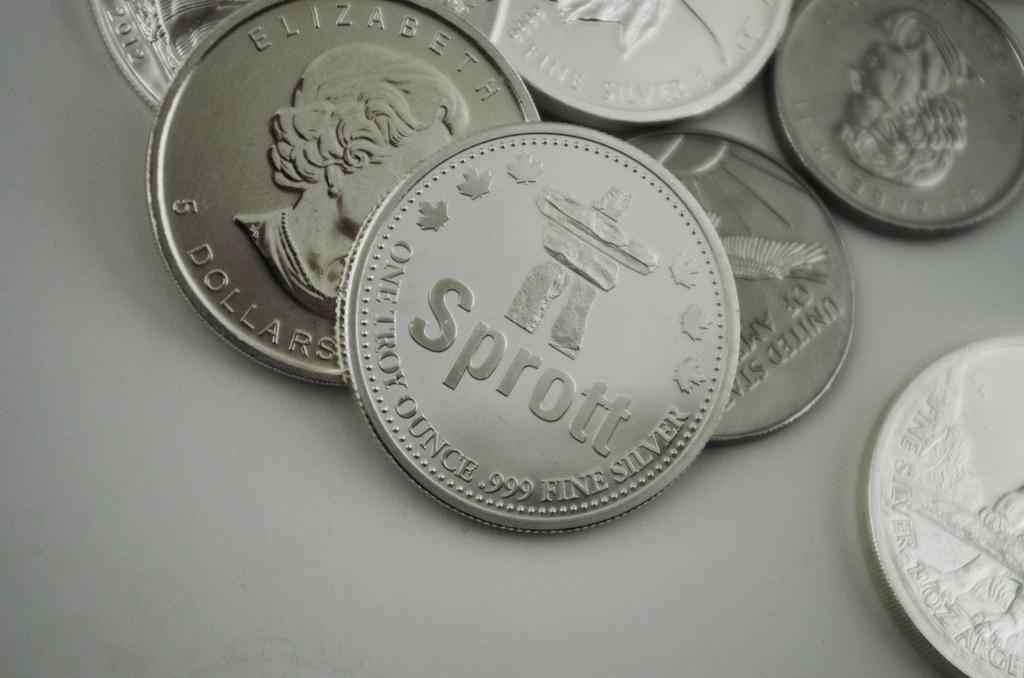<image>
Present a compact description of the photo's key features. Many silver coins on a table with one saying Sprott. 